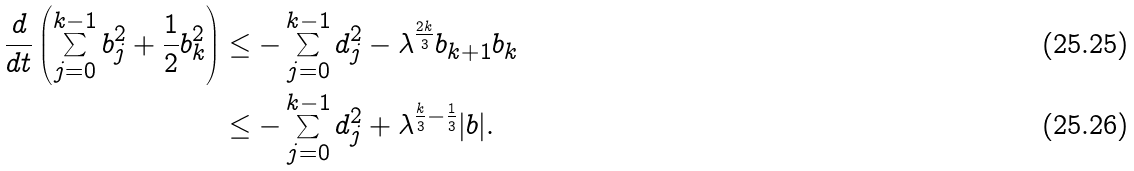Convert formula to latex. <formula><loc_0><loc_0><loc_500><loc_500>\frac { d } { d t } \left ( \sum _ { j = 0 } ^ { k - 1 } b _ { j } ^ { 2 } + \frac { 1 } { 2 } b _ { k } ^ { 2 } \right ) & \leq - \sum _ { j = 0 } ^ { k - 1 } d _ { j } ^ { 2 } - \lambda ^ { \frac { 2 k } { 3 } } b _ { k + 1 } b _ { k } \\ & \leq - \sum _ { j = 0 } ^ { k - 1 } d _ { j } ^ { 2 } + \lambda ^ { \frac { k } { 3 } - \frac { 1 } { 3 } } | b | .</formula> 